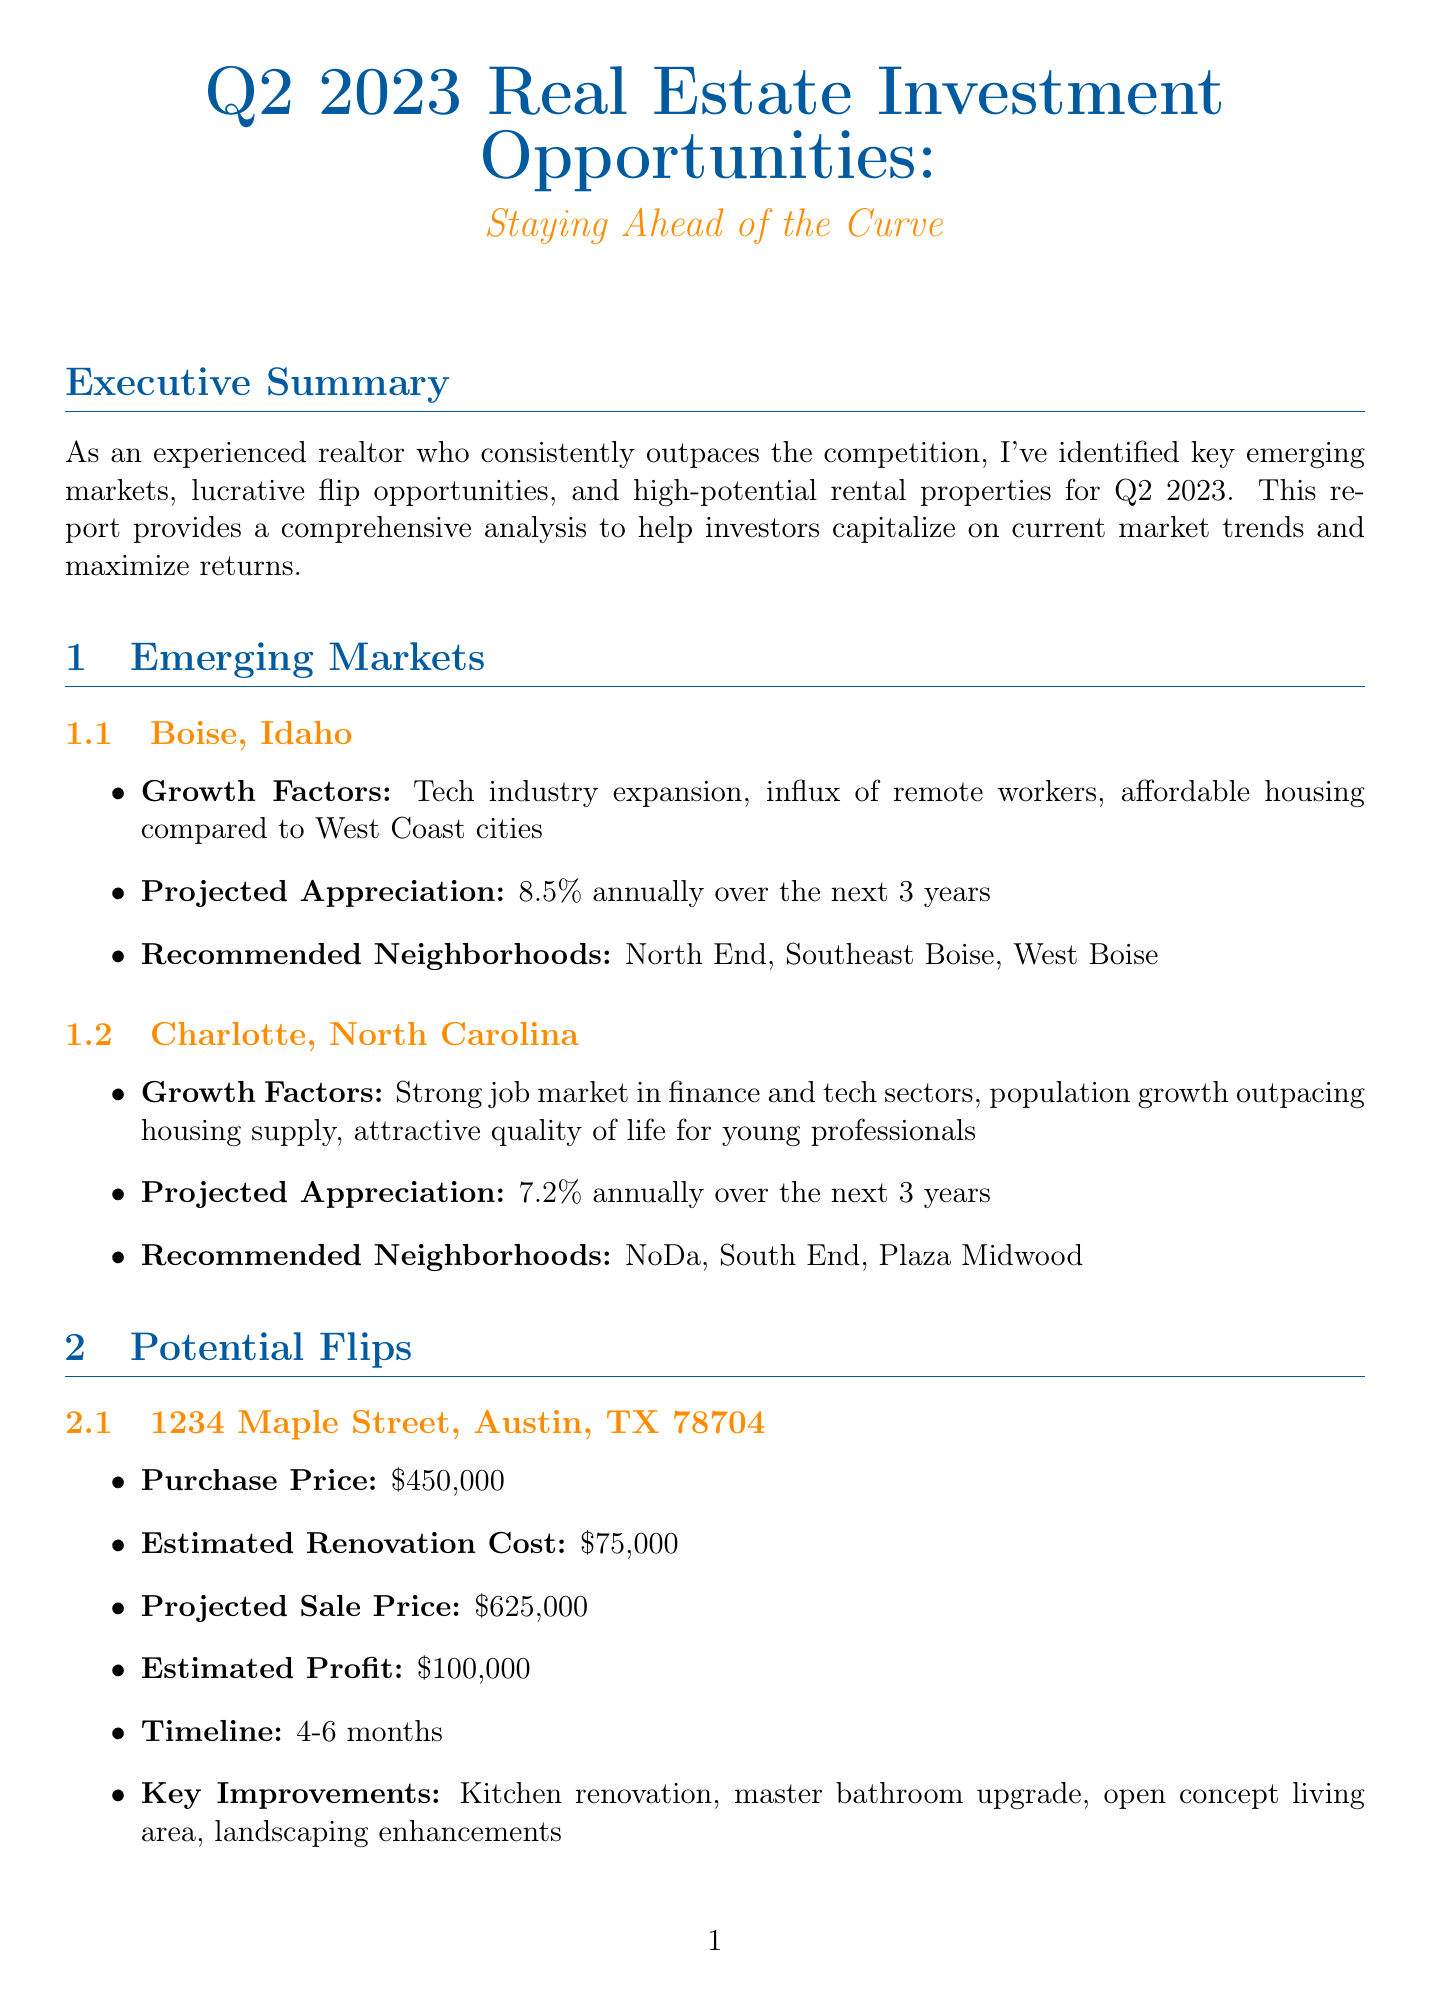What are the projected appreciation rates for Boise, Idaho? The projected appreciation rate for Boise, Idaho is 8.5% annually over the next 3 years.
Answer: 8.5% What is the estimated profit for the property at 5678 Oak Avenue, Nashville, TN? The estimated profit for the property at 5678 Oak Avenue is calculated based on the purchase price, renovation cost, and projected sale price, which amounts to $85,000.
Answer: $85,000 Which neighborhood in Charlotte, North Carolina is recommended? The document lists specific neighborhoods recommended for investment in Charlotte, North Carolina, including NoDa, South End, and Plaza Midwood.
Answer: NoDa, South End, Plaza Midwood What is the cap rate for the multi-family apartment building in Raleigh, NC? The cap rate is determined by dividing the net operating income by the purchase price, resulting in a cap rate of 6.84%.
Answer: 6.84% What is one of the investment strategies suggested in the report? The report offers various investment strategies, one of which is to target properties with value-add potential through strategic renovations.
Answer: Target properties with value-add potential What is the average monthly rent for the multi-family apartment building? The average monthly rent is calculated per unit for the multi-family apartment building located at 4321 Pine Road, which is $1,500.
Answer: $1,500 What is the timeline for renovations at 1234 Maple Street, Austin, TX? The renovation timeline for the property at 1234 Maple Street is specified in the document, with a duration of 4-6 months.
Answer: 4-6 months What is a growing trend mentioned in the report? The document highlights several market trends, including the rising demand for suburban properties with home offices as a growing trend.
Answer: Increased demand for suburban properties with home offices Which city is commended for its tech industry expansion? Boise, Idaho is notably recognized for its tech industry expansion as a key growth factor in the emerging market analysis.
Answer: Boise, Idaho 